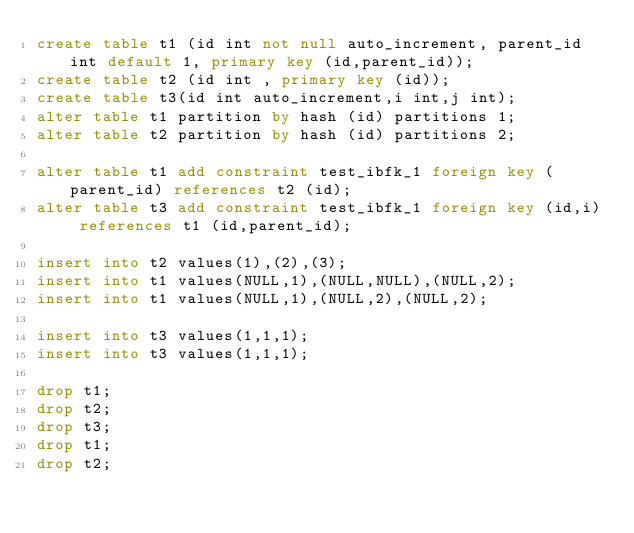<code> <loc_0><loc_0><loc_500><loc_500><_SQL_>create table t1 (id int not null auto_increment, parent_id int default 1, primary key (id,parent_id));
create table t2 (id int , primary key (id));
create table t3(id int auto_increment,i int,j int);
alter table t1 partition by hash (id) partitions 1;
alter table t2 partition by hash (id) partitions 2;

alter table t1 add constraint test_ibfk_1 foreign key (parent_id) references t2 (id);
alter table t3 add constraint test_ibfk_1 foreign key (id,i) references t1 (id,parent_id);

insert into t2 values(1),(2),(3);
insert into t1 values(NULL,1),(NULL,NULL),(NULL,2);
insert into t1 values(NULL,1),(NULL,2),(NULL,2);

insert into t3 values(1,1,1);
insert into t3 values(1,1,1);

drop t1;
drop t2;
drop t3;
drop t1;
drop t2;

</code> 